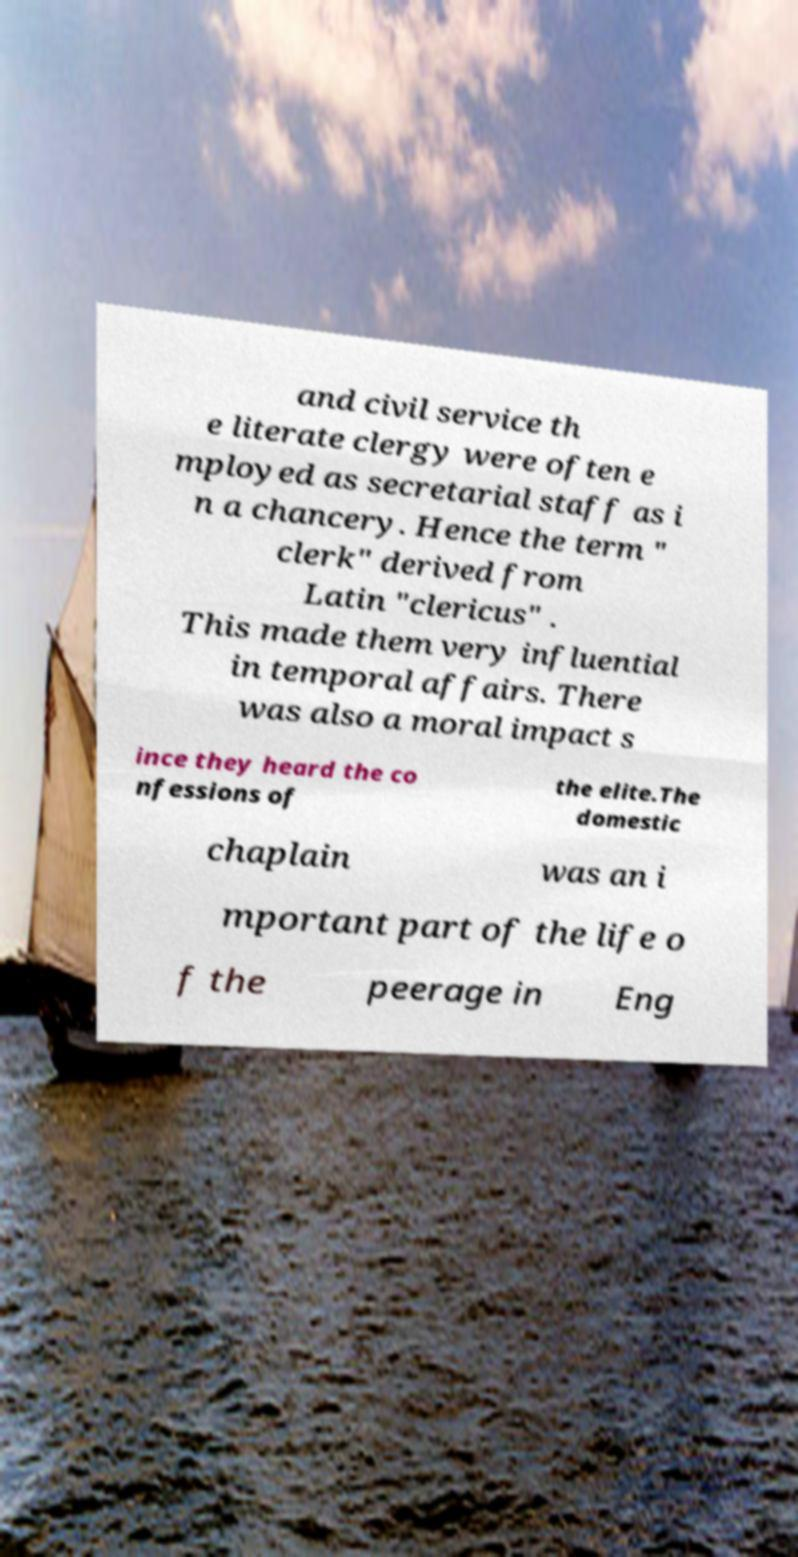Please identify and transcribe the text found in this image. and civil service th e literate clergy were often e mployed as secretarial staff as i n a chancery. Hence the term " clerk" derived from Latin "clericus" . This made them very influential in temporal affairs. There was also a moral impact s ince they heard the co nfessions of the elite.The domestic chaplain was an i mportant part of the life o f the peerage in Eng 